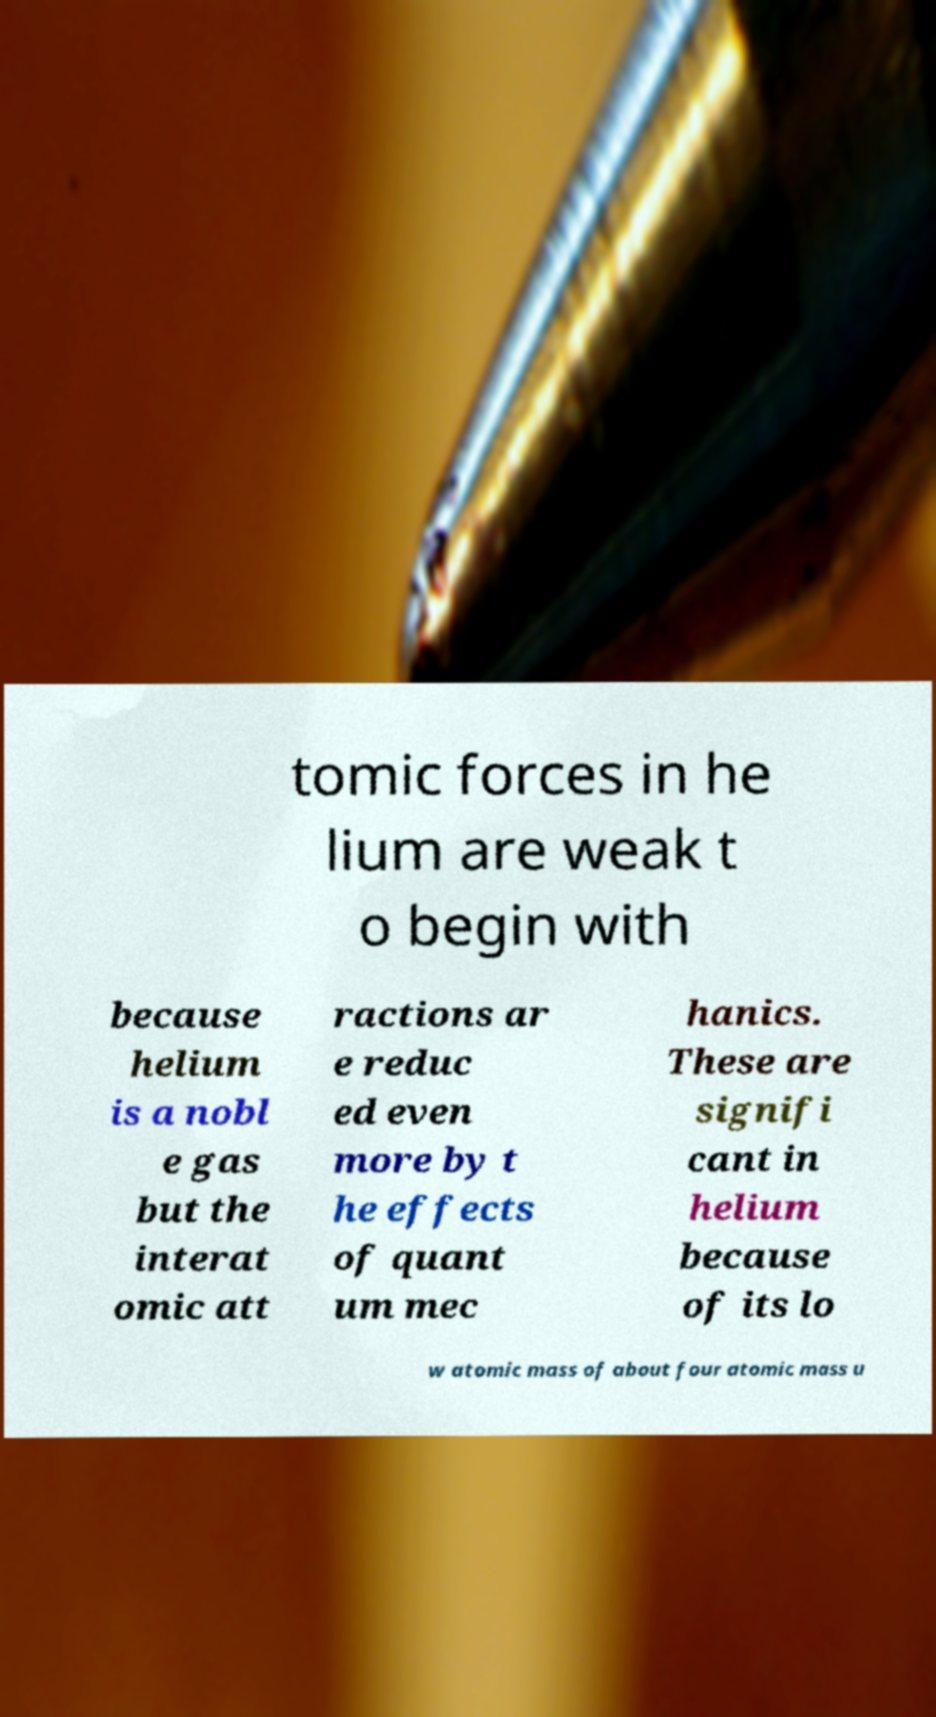Could you extract and type out the text from this image? tomic forces in he lium are weak t o begin with because helium is a nobl e gas but the interat omic att ractions ar e reduc ed even more by t he effects of quant um mec hanics. These are signifi cant in helium because of its lo w atomic mass of about four atomic mass u 